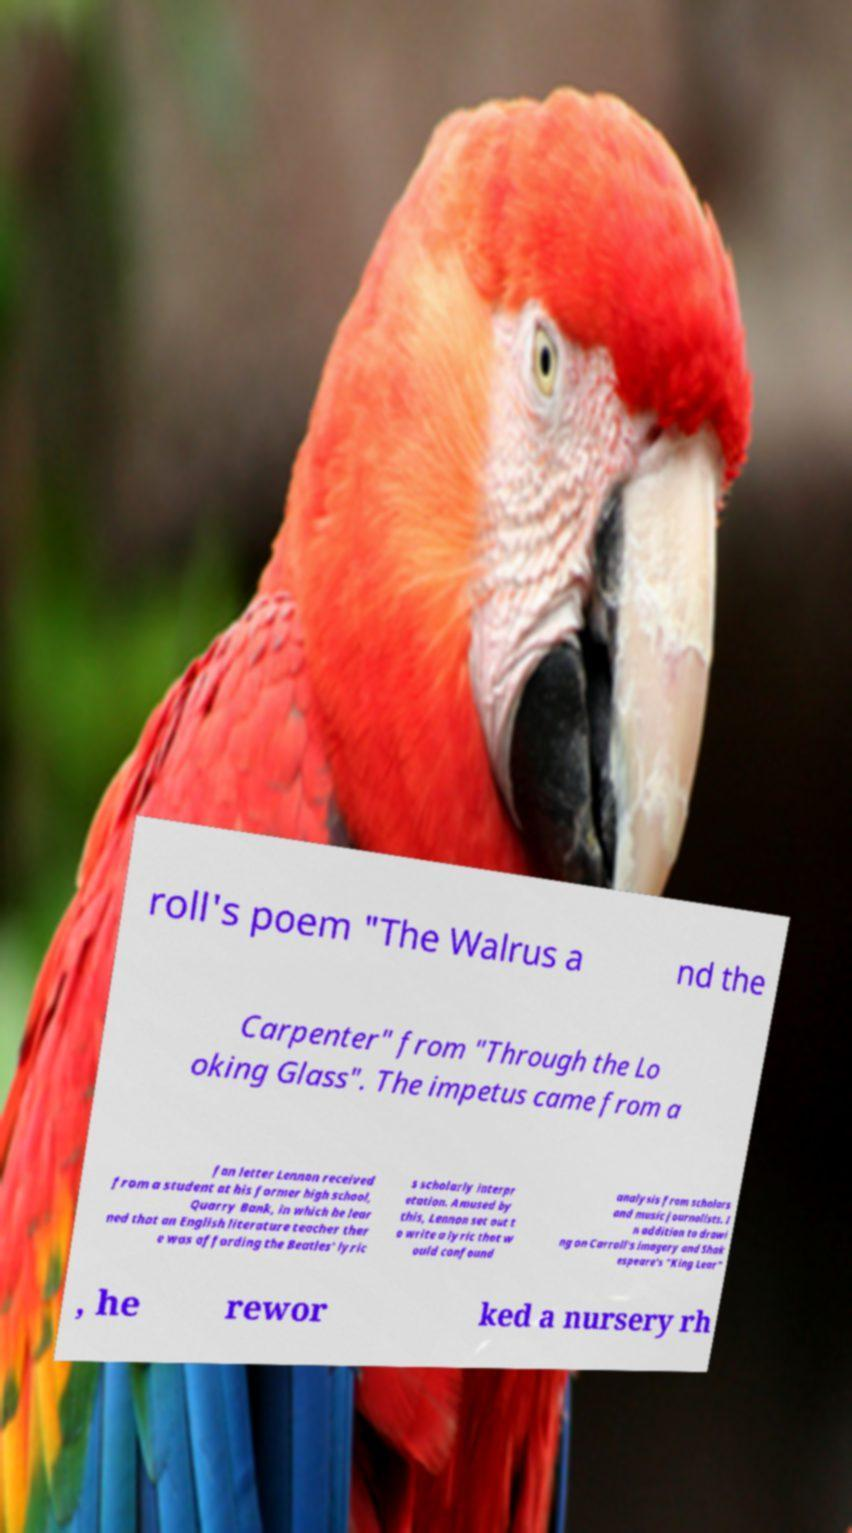Could you extract and type out the text from this image? roll's poem "The Walrus a nd the Carpenter" from "Through the Lo oking Glass". The impetus came from a fan letter Lennon received from a student at his former high school, Quarry Bank, in which he lear ned that an English literature teacher ther e was affording the Beatles' lyric s scholarly interpr etation. Amused by this, Lennon set out t o write a lyric that w ould confound analysis from scholars and music journalists. I n addition to drawi ng on Carroll's imagery and Shak espeare's "King Lear" , he rewor ked a nursery rh 